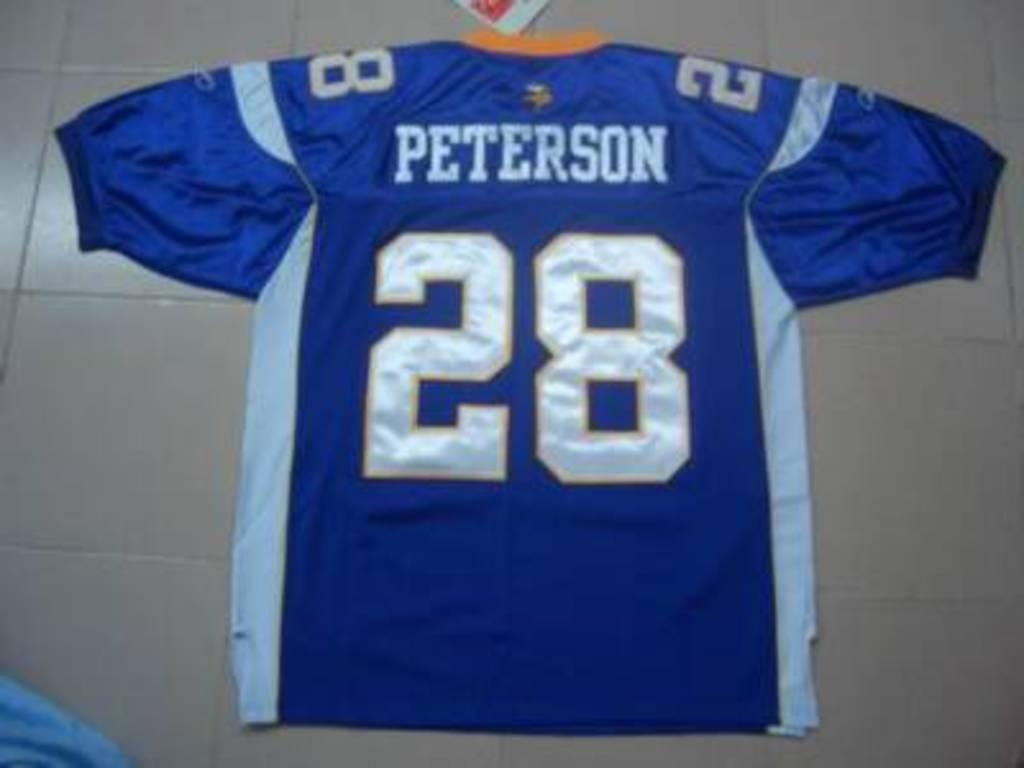Provide a one-sentence caption for the provided image. A large blue Peterson, number 28 football jersey. 